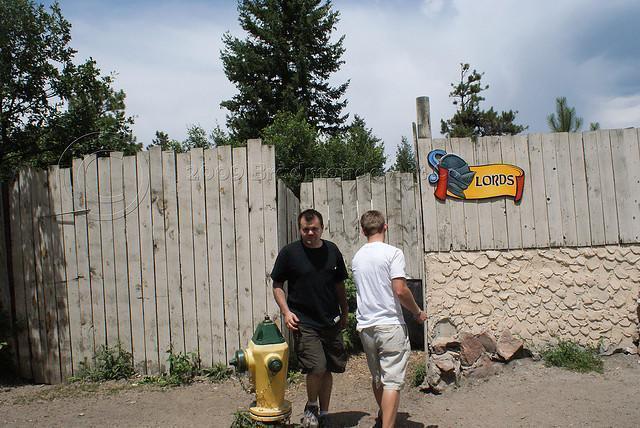What does the man in white need to use?
From the following four choices, select the correct answer to address the question.
Options: Grill, emergency exit, restroom, sword. Restroom. 